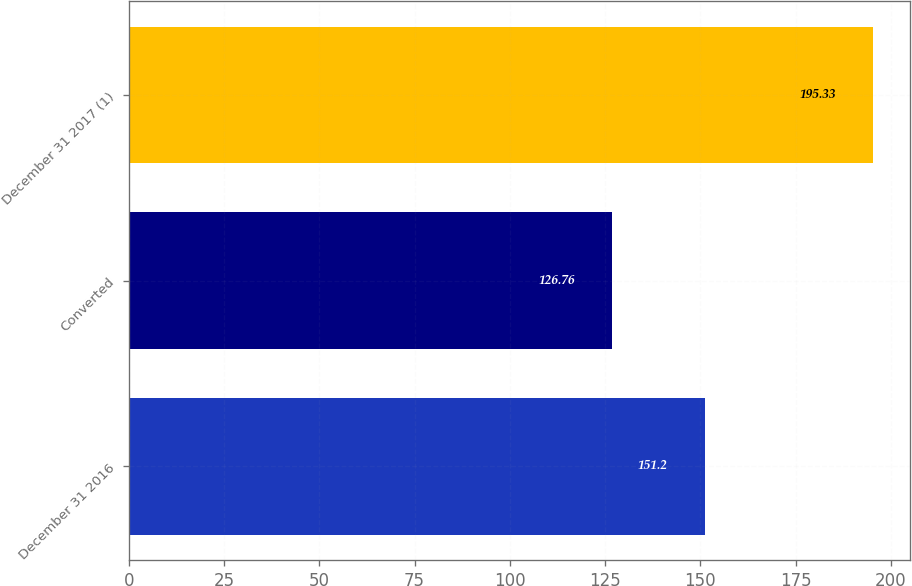<chart> <loc_0><loc_0><loc_500><loc_500><bar_chart><fcel>December 31 2016<fcel>Converted<fcel>December 31 2017 (1)<nl><fcel>151.2<fcel>126.76<fcel>195.33<nl></chart> 